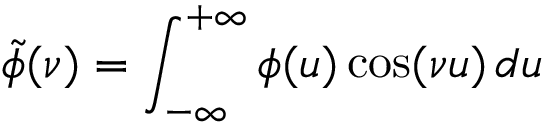Convert formula to latex. <formula><loc_0><loc_0><loc_500><loc_500>\tilde { \phi } ( \nu ) = \int _ { - \infty } ^ { + \infty } \phi ( u ) \cos ( \nu u ) \, d u</formula> 